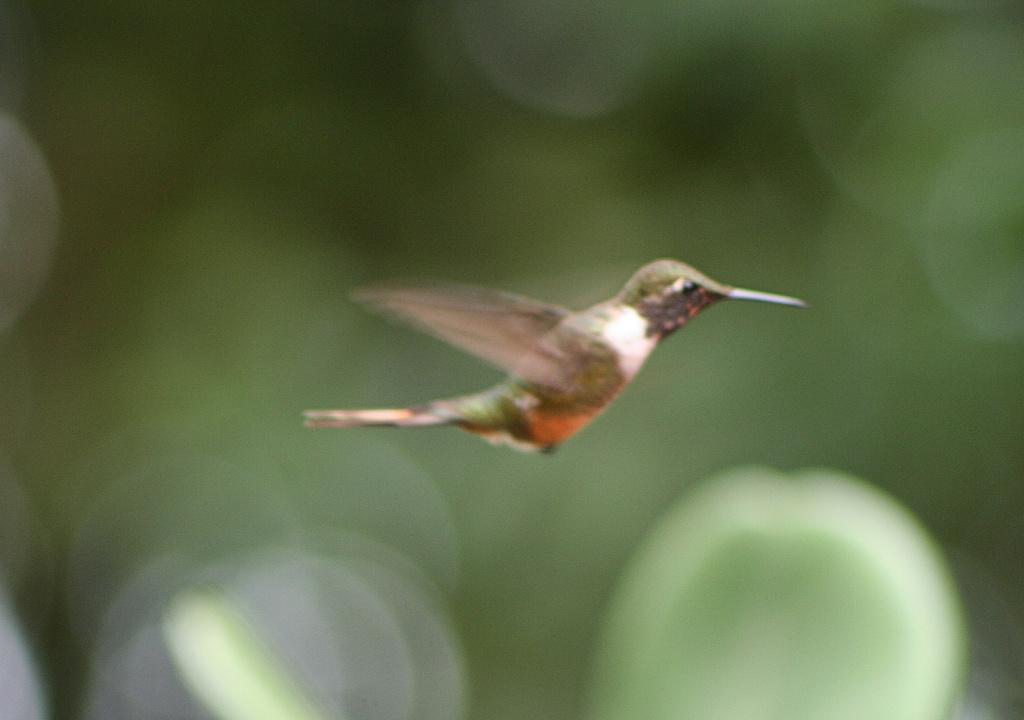What is the main subject of the image? There is a bird flying in the air in the image. How would you describe the background of the image? The background of the image is blurry and green in color. Where is the shoe placed on the shelf in the image? There is no shoe or shelf present in the image; it features a bird flying in the air with a blurry and green background. 